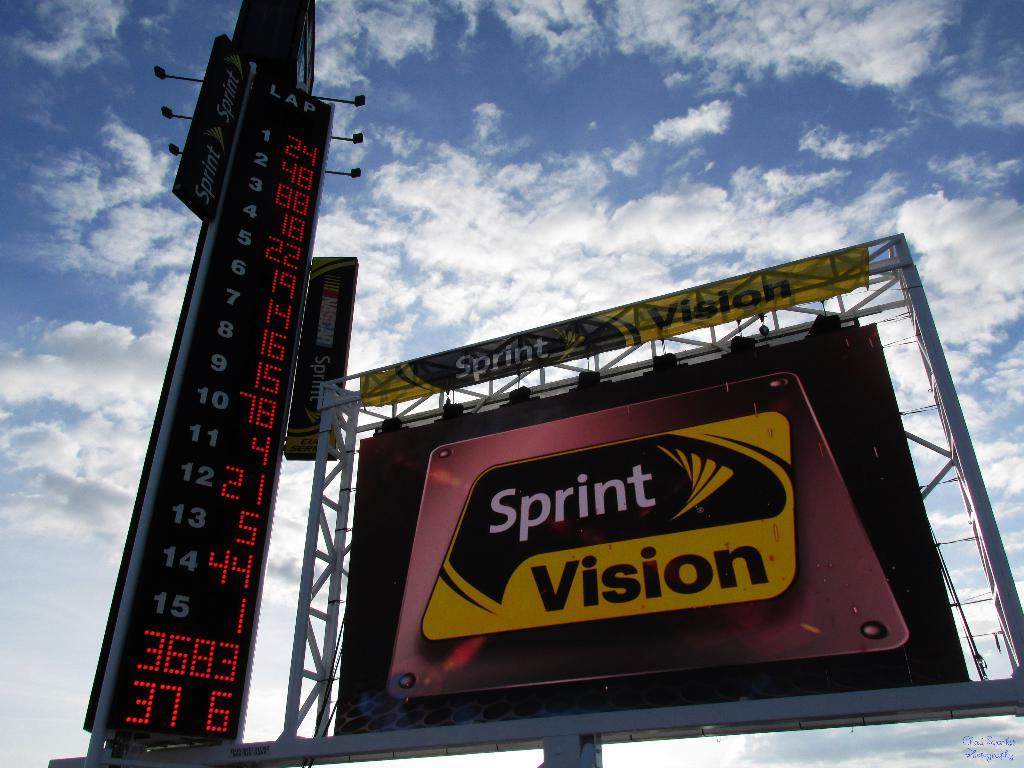<image>
Give a short and clear explanation of the subsequent image. a big bill board for Sprint Vision is next to a Lap counter 